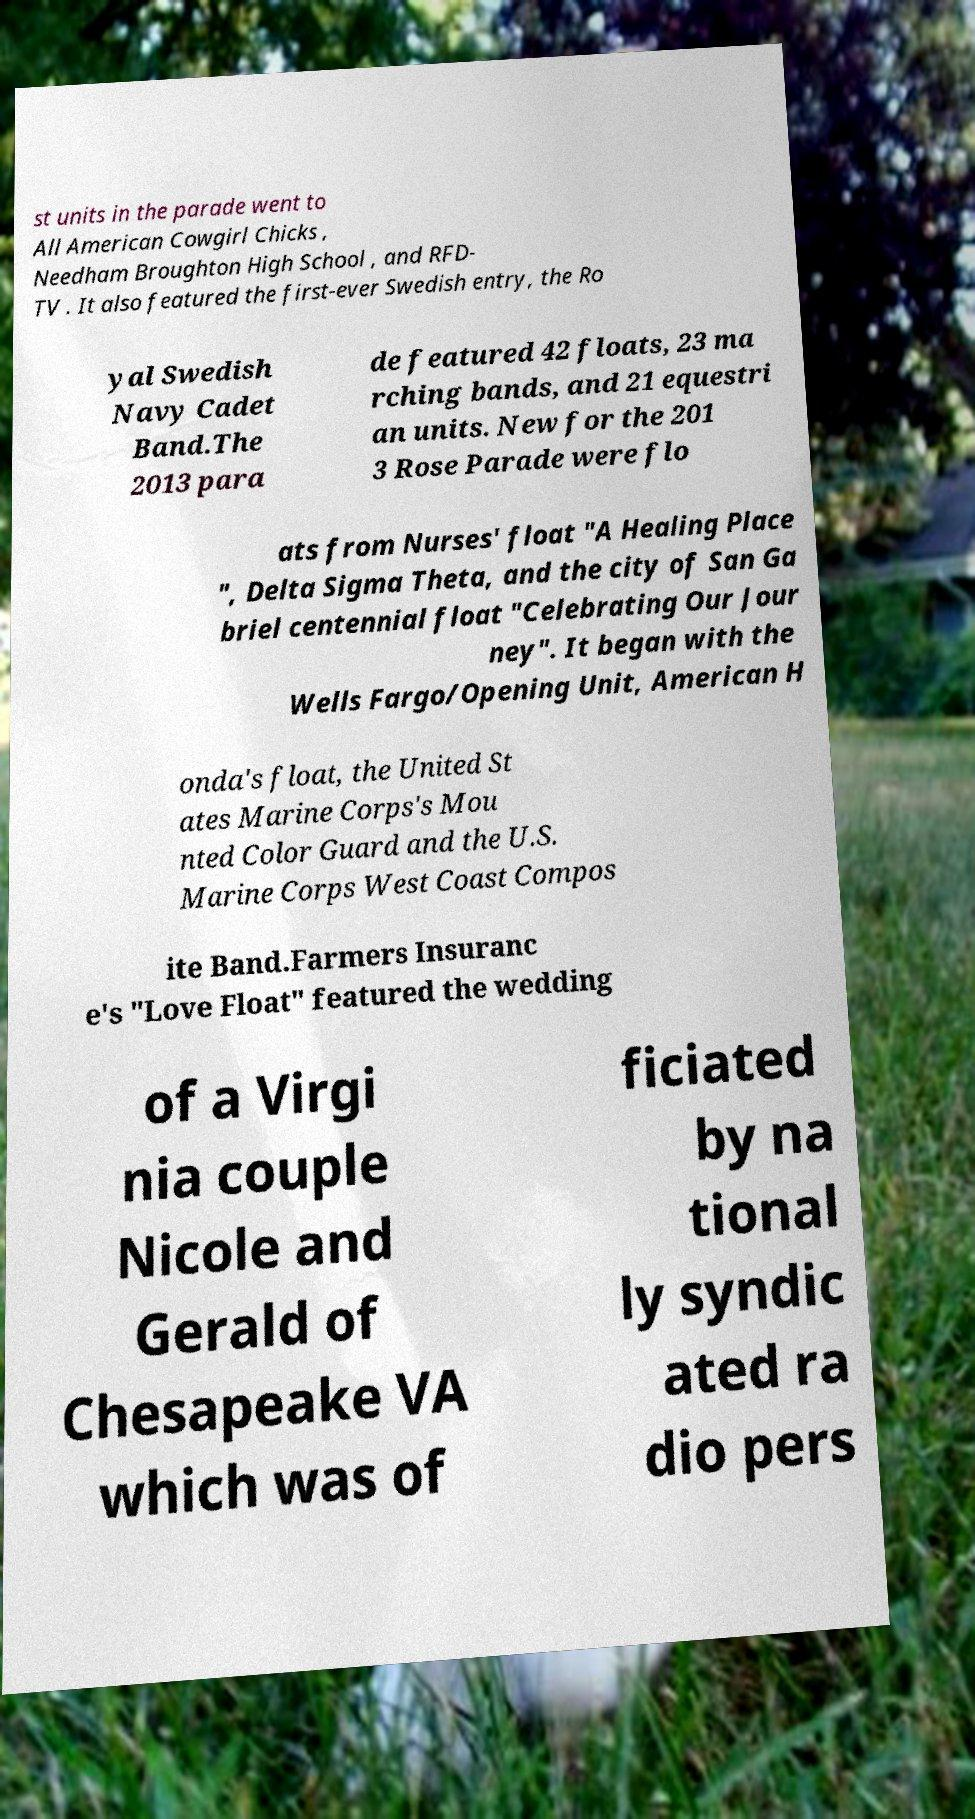I need the written content from this picture converted into text. Can you do that? st units in the parade went to All American Cowgirl Chicks , Needham Broughton High School , and RFD- TV . It also featured the first-ever Swedish entry, the Ro yal Swedish Navy Cadet Band.The 2013 para de featured 42 floats, 23 ma rching bands, and 21 equestri an units. New for the 201 3 Rose Parade were flo ats from Nurses' float "A Healing Place ", Delta Sigma Theta, and the city of San Ga briel centennial float "Celebrating Our Jour ney". It began with the Wells Fargo/Opening Unit, American H onda's float, the United St ates Marine Corps's Mou nted Color Guard and the U.S. Marine Corps West Coast Compos ite Band.Farmers Insuranc e's "Love Float" featured the wedding of a Virgi nia couple Nicole and Gerald of Chesapeake VA which was of ficiated by na tional ly syndic ated ra dio pers 